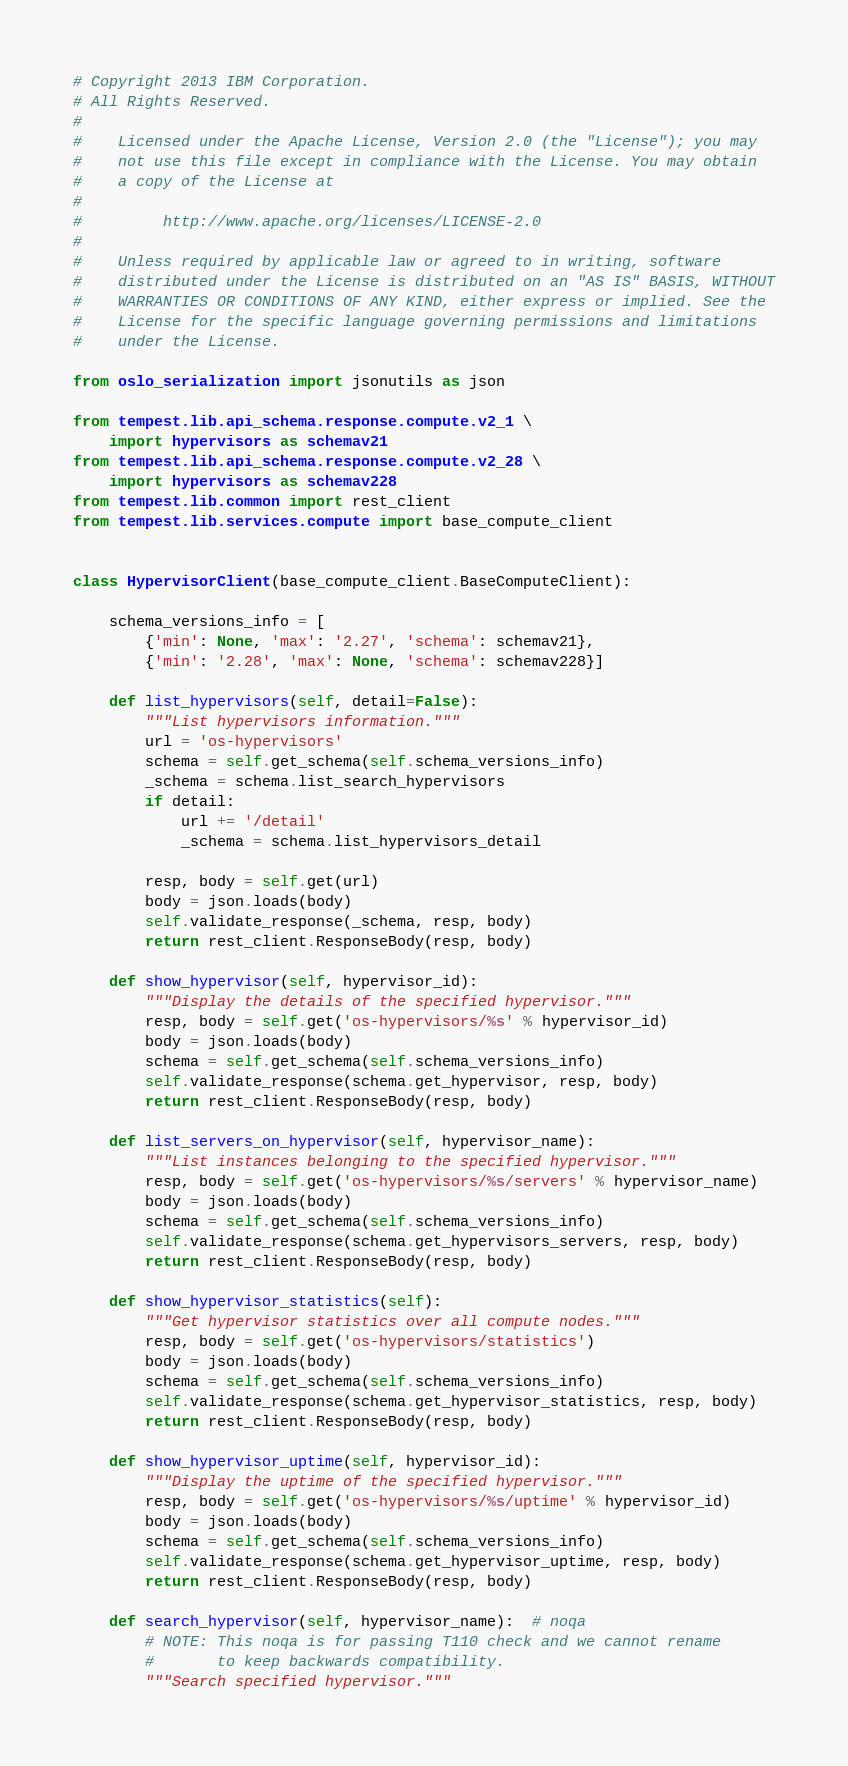<code> <loc_0><loc_0><loc_500><loc_500><_Python_># Copyright 2013 IBM Corporation.
# All Rights Reserved.
#
#    Licensed under the Apache License, Version 2.0 (the "License"); you may
#    not use this file except in compliance with the License. You may obtain
#    a copy of the License at
#
#         http://www.apache.org/licenses/LICENSE-2.0
#
#    Unless required by applicable law or agreed to in writing, software
#    distributed under the License is distributed on an "AS IS" BASIS, WITHOUT
#    WARRANTIES OR CONDITIONS OF ANY KIND, either express or implied. See the
#    License for the specific language governing permissions and limitations
#    under the License.

from oslo_serialization import jsonutils as json

from tempest.lib.api_schema.response.compute.v2_1 \
    import hypervisors as schemav21
from tempest.lib.api_schema.response.compute.v2_28 \
    import hypervisors as schemav228
from tempest.lib.common import rest_client
from tempest.lib.services.compute import base_compute_client


class HypervisorClient(base_compute_client.BaseComputeClient):

    schema_versions_info = [
        {'min': None, 'max': '2.27', 'schema': schemav21},
        {'min': '2.28', 'max': None, 'schema': schemav228}]

    def list_hypervisors(self, detail=False):
        """List hypervisors information."""
        url = 'os-hypervisors'
        schema = self.get_schema(self.schema_versions_info)
        _schema = schema.list_search_hypervisors
        if detail:
            url += '/detail'
            _schema = schema.list_hypervisors_detail

        resp, body = self.get(url)
        body = json.loads(body)
        self.validate_response(_schema, resp, body)
        return rest_client.ResponseBody(resp, body)

    def show_hypervisor(self, hypervisor_id):
        """Display the details of the specified hypervisor."""
        resp, body = self.get('os-hypervisors/%s' % hypervisor_id)
        body = json.loads(body)
        schema = self.get_schema(self.schema_versions_info)
        self.validate_response(schema.get_hypervisor, resp, body)
        return rest_client.ResponseBody(resp, body)

    def list_servers_on_hypervisor(self, hypervisor_name):
        """List instances belonging to the specified hypervisor."""
        resp, body = self.get('os-hypervisors/%s/servers' % hypervisor_name)
        body = json.loads(body)
        schema = self.get_schema(self.schema_versions_info)
        self.validate_response(schema.get_hypervisors_servers, resp, body)
        return rest_client.ResponseBody(resp, body)

    def show_hypervisor_statistics(self):
        """Get hypervisor statistics over all compute nodes."""
        resp, body = self.get('os-hypervisors/statistics')
        body = json.loads(body)
        schema = self.get_schema(self.schema_versions_info)
        self.validate_response(schema.get_hypervisor_statistics, resp, body)
        return rest_client.ResponseBody(resp, body)

    def show_hypervisor_uptime(self, hypervisor_id):
        """Display the uptime of the specified hypervisor."""
        resp, body = self.get('os-hypervisors/%s/uptime' % hypervisor_id)
        body = json.loads(body)
        schema = self.get_schema(self.schema_versions_info)
        self.validate_response(schema.get_hypervisor_uptime, resp, body)
        return rest_client.ResponseBody(resp, body)

    def search_hypervisor(self, hypervisor_name):  # noqa
        # NOTE: This noqa is for passing T110 check and we cannot rename
        #       to keep backwards compatibility.
        """Search specified hypervisor."""</code> 